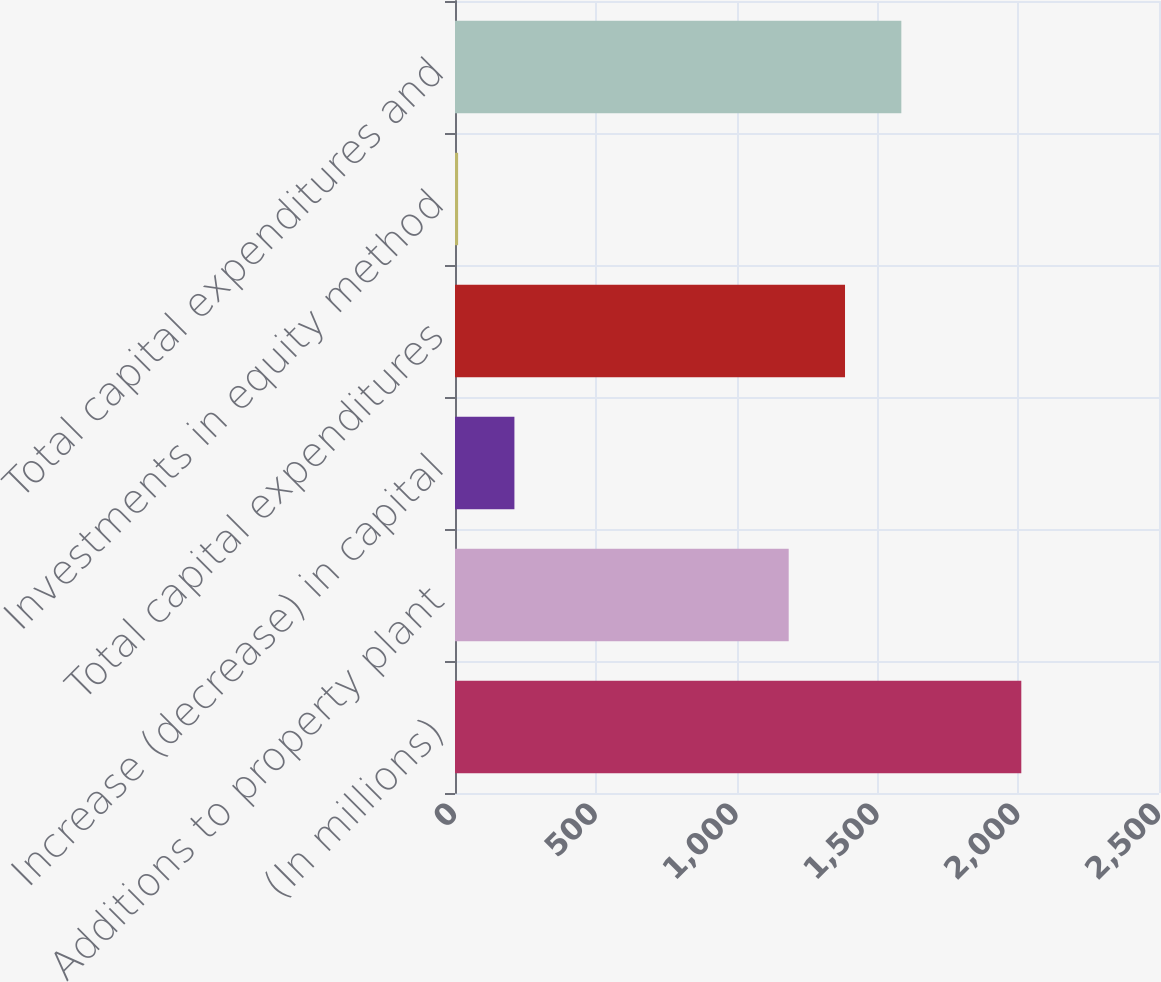Convert chart to OTSL. <chart><loc_0><loc_0><loc_500><loc_500><bar_chart><fcel>(In millions)<fcel>Additions to property plant<fcel>Increase (decrease) in capital<fcel>Total capital expenditures<fcel>Investments in equity method<fcel>Total capital expenditures and<nl><fcel>2011<fcel>1185<fcel>211<fcel>1385<fcel>11<fcel>1585<nl></chart> 